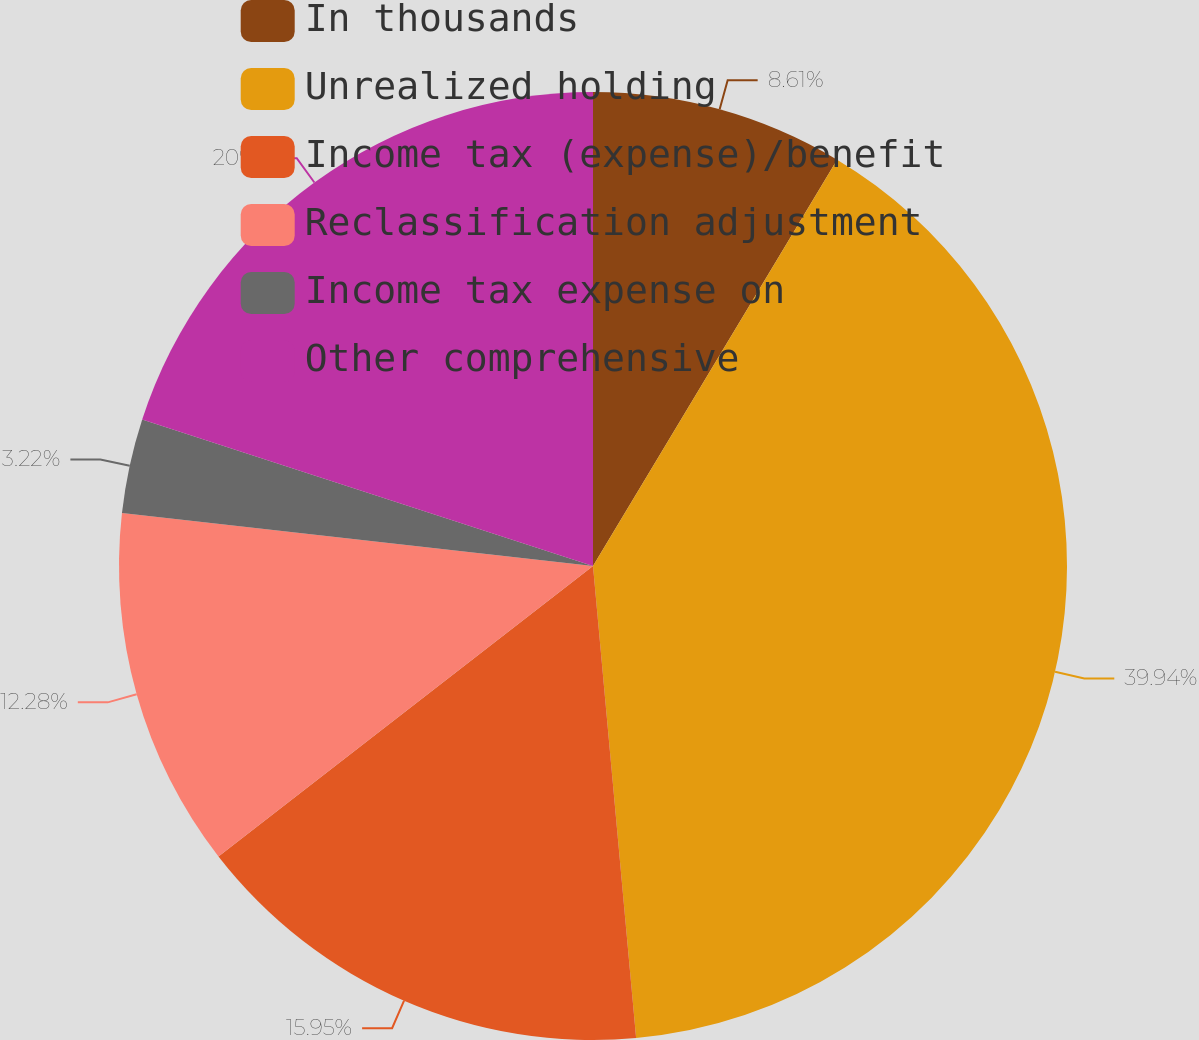Convert chart. <chart><loc_0><loc_0><loc_500><loc_500><pie_chart><fcel>In thousands<fcel>Unrealized holding<fcel>Income tax (expense)/benefit<fcel>Reclassification adjustment<fcel>Income tax expense on<fcel>Other comprehensive<nl><fcel>8.61%<fcel>39.94%<fcel>15.95%<fcel>12.28%<fcel>3.22%<fcel>20.0%<nl></chart> 